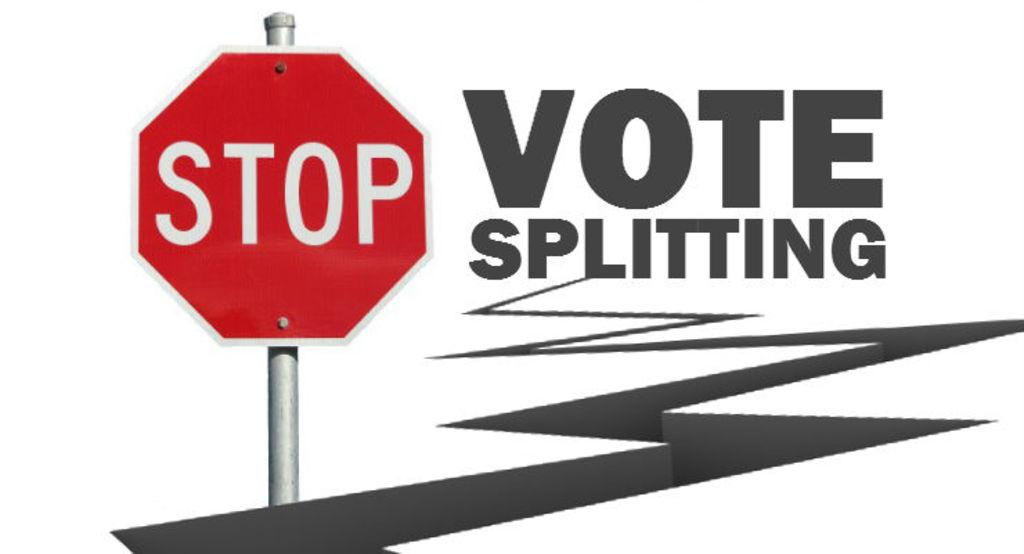<image>
Present a compact description of the photo's key features. A Stop sign is in front of a zig zag line ending in the words Vote Splitting. 